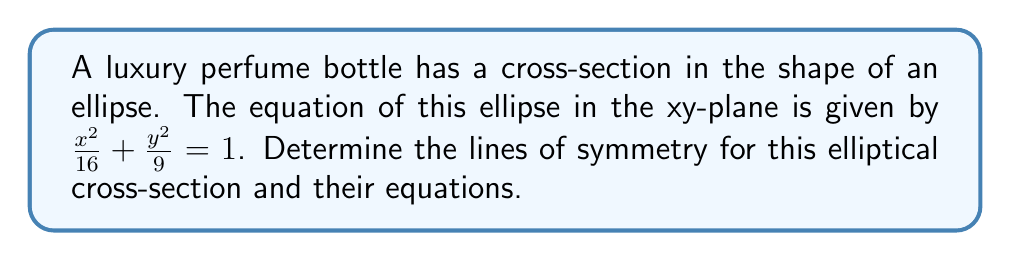Teach me how to tackle this problem. To determine the lines of symmetry for the elliptical cross-section, we follow these steps:

1. Recognize that the general equation of an ellipse centered at the origin is:
   $$\frac{x^2}{a^2} + \frac{y^2}{b^2} = 1$$
   where $a$ and $b$ are the lengths of the semi-major and semi-minor axes.

2. In our case, $\frac{x^2}{16} + \frac{y^2}{9} = 1$, so $a^2 = 16$ and $b^2 = 9$.

3. The ellipse is centered at the origin (0, 0) because there are no linear terms in x or y.

4. An ellipse always has two lines of symmetry:
   a) The major axis (along the longer dimension)
   b) The minor axis (along the shorter dimension)

5. To determine which is the major axis:
   $a = \sqrt{16} = 4$
   $b = \sqrt{9} = 3$
   Since $a > b$, the major axis is along the x-axis.

6. The equations of the lines of symmetry are:
   - Major axis (x-axis): $y = 0$
   - Minor axis (y-axis): $x = 0$

7. We can visualize this ellipse:

[asy]
import graph;
size(200);
real f(real x) {return sqrt(9*(1-x^2/16));}
real g(real x) {return -sqrt(9*(1-x^2/16));}
draw(graph(f,-4,4));
draw(graph(g,-4,4));
draw((-5,0)--(5,0),arrow=Arrow);
draw((0,-4)--(0,4),arrow=Arrow);
label("x",(5,0),E);
label("y",(0,4),N);
[/asy]

Therefore, the lines of symmetry for this elliptical cross-section are the x-axis and y-axis.
Answer: $y = 0$ and $x = 0$ 